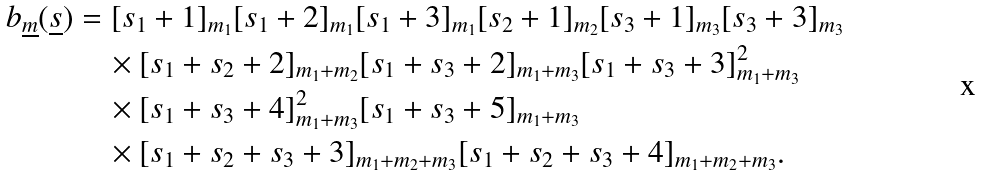<formula> <loc_0><loc_0><loc_500><loc_500>b _ { \underline { m } } ( \underline { s } ) & = [ s _ { 1 } + 1 ] _ { m _ { 1 } } [ s _ { 1 } + 2 ] _ { m _ { 1 } } [ s _ { 1 } + 3 ] _ { m _ { 1 } } [ s _ { 2 } + 1 ] _ { m _ { 2 } } [ s _ { 3 } + 1 ] _ { m _ { 3 } } [ s _ { 3 } + 3 ] _ { m _ { 3 } } \\ & \quad \times [ s _ { 1 } + s _ { 2 } + 2 ] _ { m _ { 1 } + m _ { 2 } } [ s _ { 1 } + s _ { 3 } + 2 ] _ { m _ { 1 } + m _ { 3 } } [ s _ { 1 } + s _ { 3 } + 3 ] _ { m _ { 1 } + m _ { 3 } } ^ { 2 } \\ & \quad \times [ s _ { 1 } + s _ { 3 } + 4 ] _ { m _ { 1 } + m _ { 3 } } ^ { 2 } [ s _ { 1 } + s _ { 3 } + 5 ] _ { m _ { 1 } + m _ { 3 } } \\ & \quad \times [ s _ { 1 } + s _ { 2 } + s _ { 3 } + 3 ] _ { m _ { 1 } + m _ { 2 } + m _ { 3 } } [ s _ { 1 } + s _ { 2 } + s _ { 3 } + 4 ] _ { m _ { 1 } + m _ { 2 } + m _ { 3 } } .</formula> 